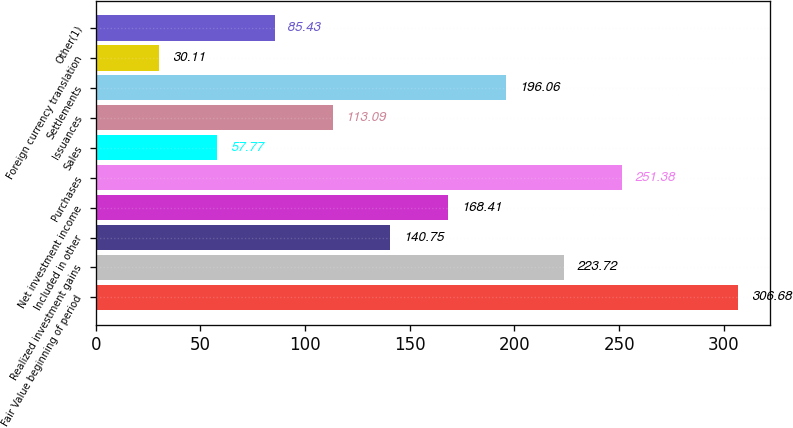Convert chart to OTSL. <chart><loc_0><loc_0><loc_500><loc_500><bar_chart><fcel>Fair Value beginning of period<fcel>Realized investment gains<fcel>Included in other<fcel>Net investment income<fcel>Purchases<fcel>Sales<fcel>Issuances<fcel>Settlements<fcel>Foreign currency translation<fcel>Other(1)<nl><fcel>306.68<fcel>223.72<fcel>140.75<fcel>168.41<fcel>251.38<fcel>57.77<fcel>113.09<fcel>196.06<fcel>30.11<fcel>85.43<nl></chart> 